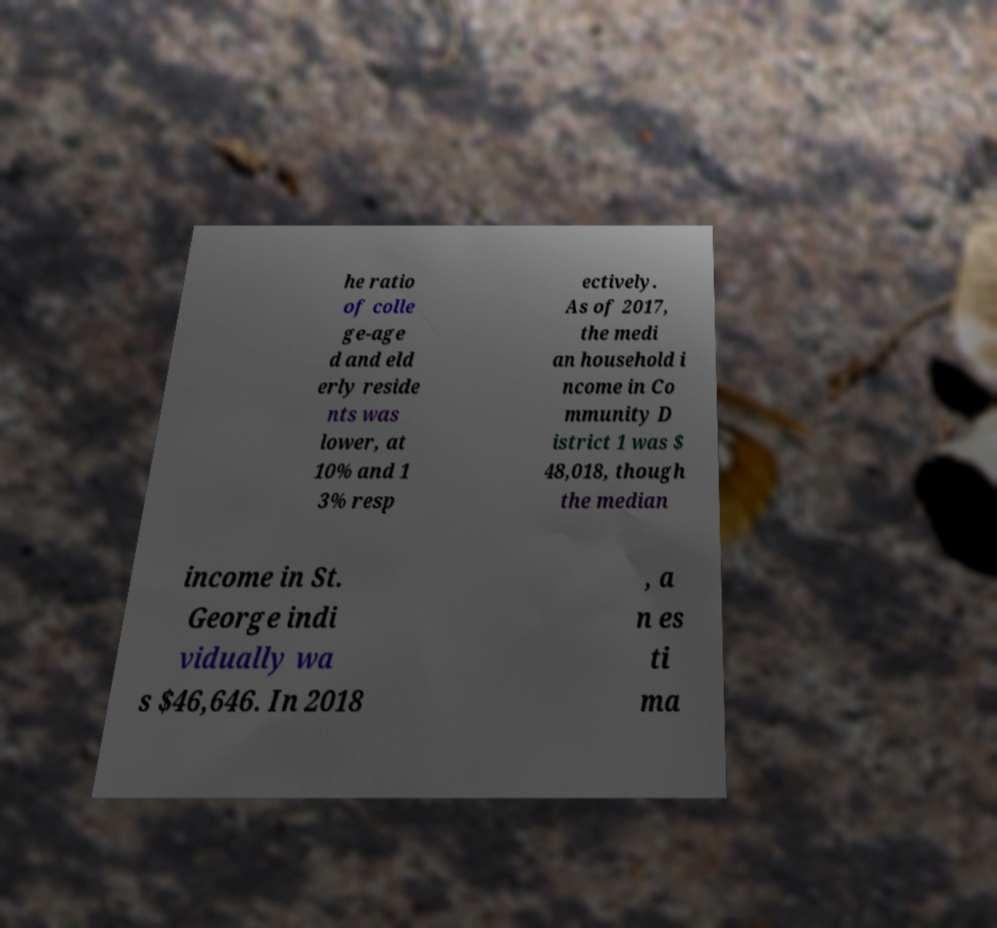I need the written content from this picture converted into text. Can you do that? he ratio of colle ge-age d and eld erly reside nts was lower, at 10% and 1 3% resp ectively. As of 2017, the medi an household i ncome in Co mmunity D istrict 1 was $ 48,018, though the median income in St. George indi vidually wa s $46,646. In 2018 , a n es ti ma 